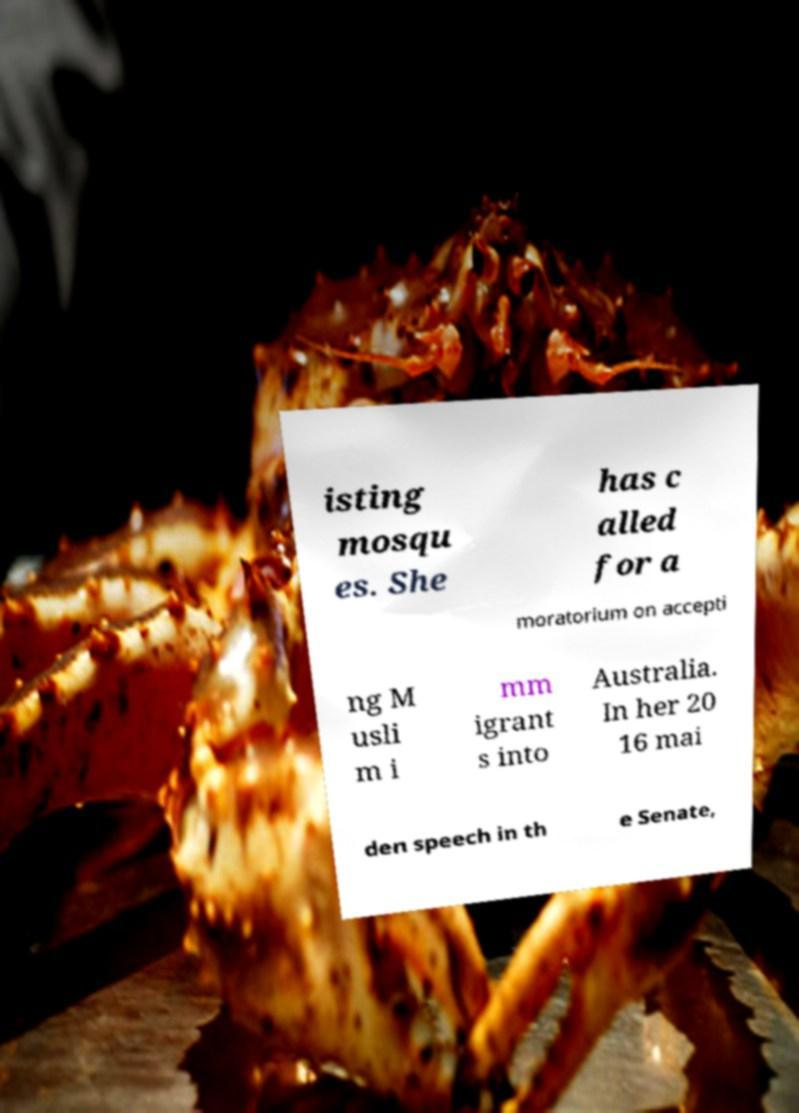Can you accurately transcribe the text from the provided image for me? isting mosqu es. She has c alled for a moratorium on accepti ng M usli m i mm igrant s into Australia. In her 20 16 mai den speech in th e Senate, 